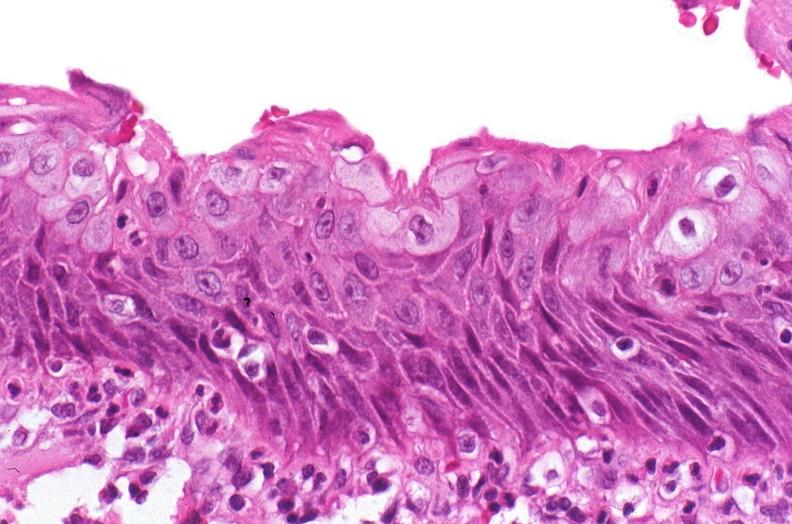does this image show renal pelvis, squamous metaplasia due to chronic urolithiasis?
Answer the question using a single word or phrase. Yes 